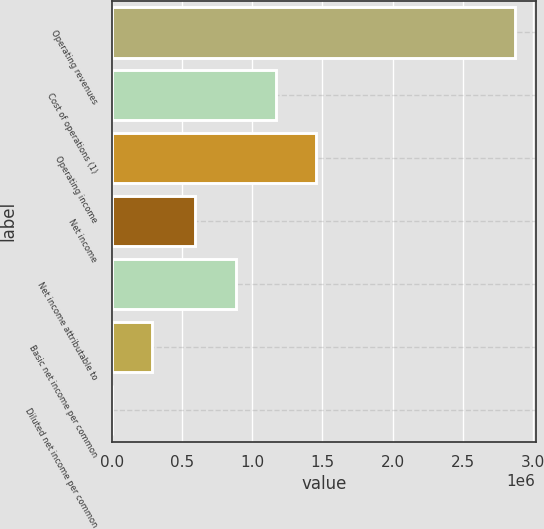Convert chart to OTSL. <chart><loc_0><loc_0><loc_500><loc_500><bar_chart><fcel>Operating revenues<fcel>Cost of operations (1)<fcel>Operating income<fcel>Net income<fcel>Net income attributable to<fcel>Basic net income per common<fcel>Diluted net income per common<nl><fcel>2.87596e+06<fcel>1.16922e+06<fcel>1.45681e+06<fcel>594025<fcel>881621<fcel>287597<fcel>1.6<nl></chart> 